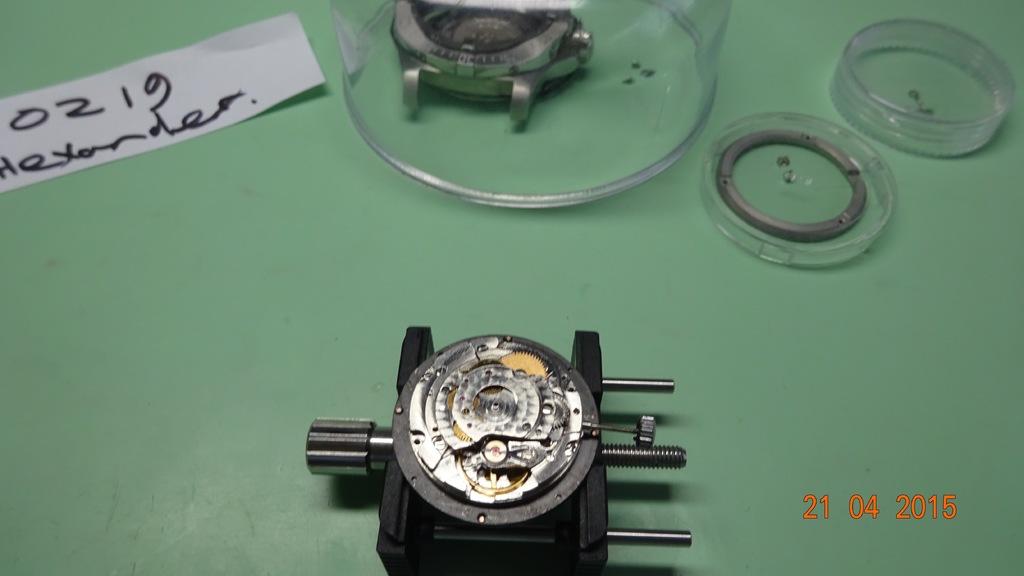What are the numbers in the top left?
Offer a very short reply. 0219. When was the photo taken?
Provide a succinct answer. 21 04 2015. 